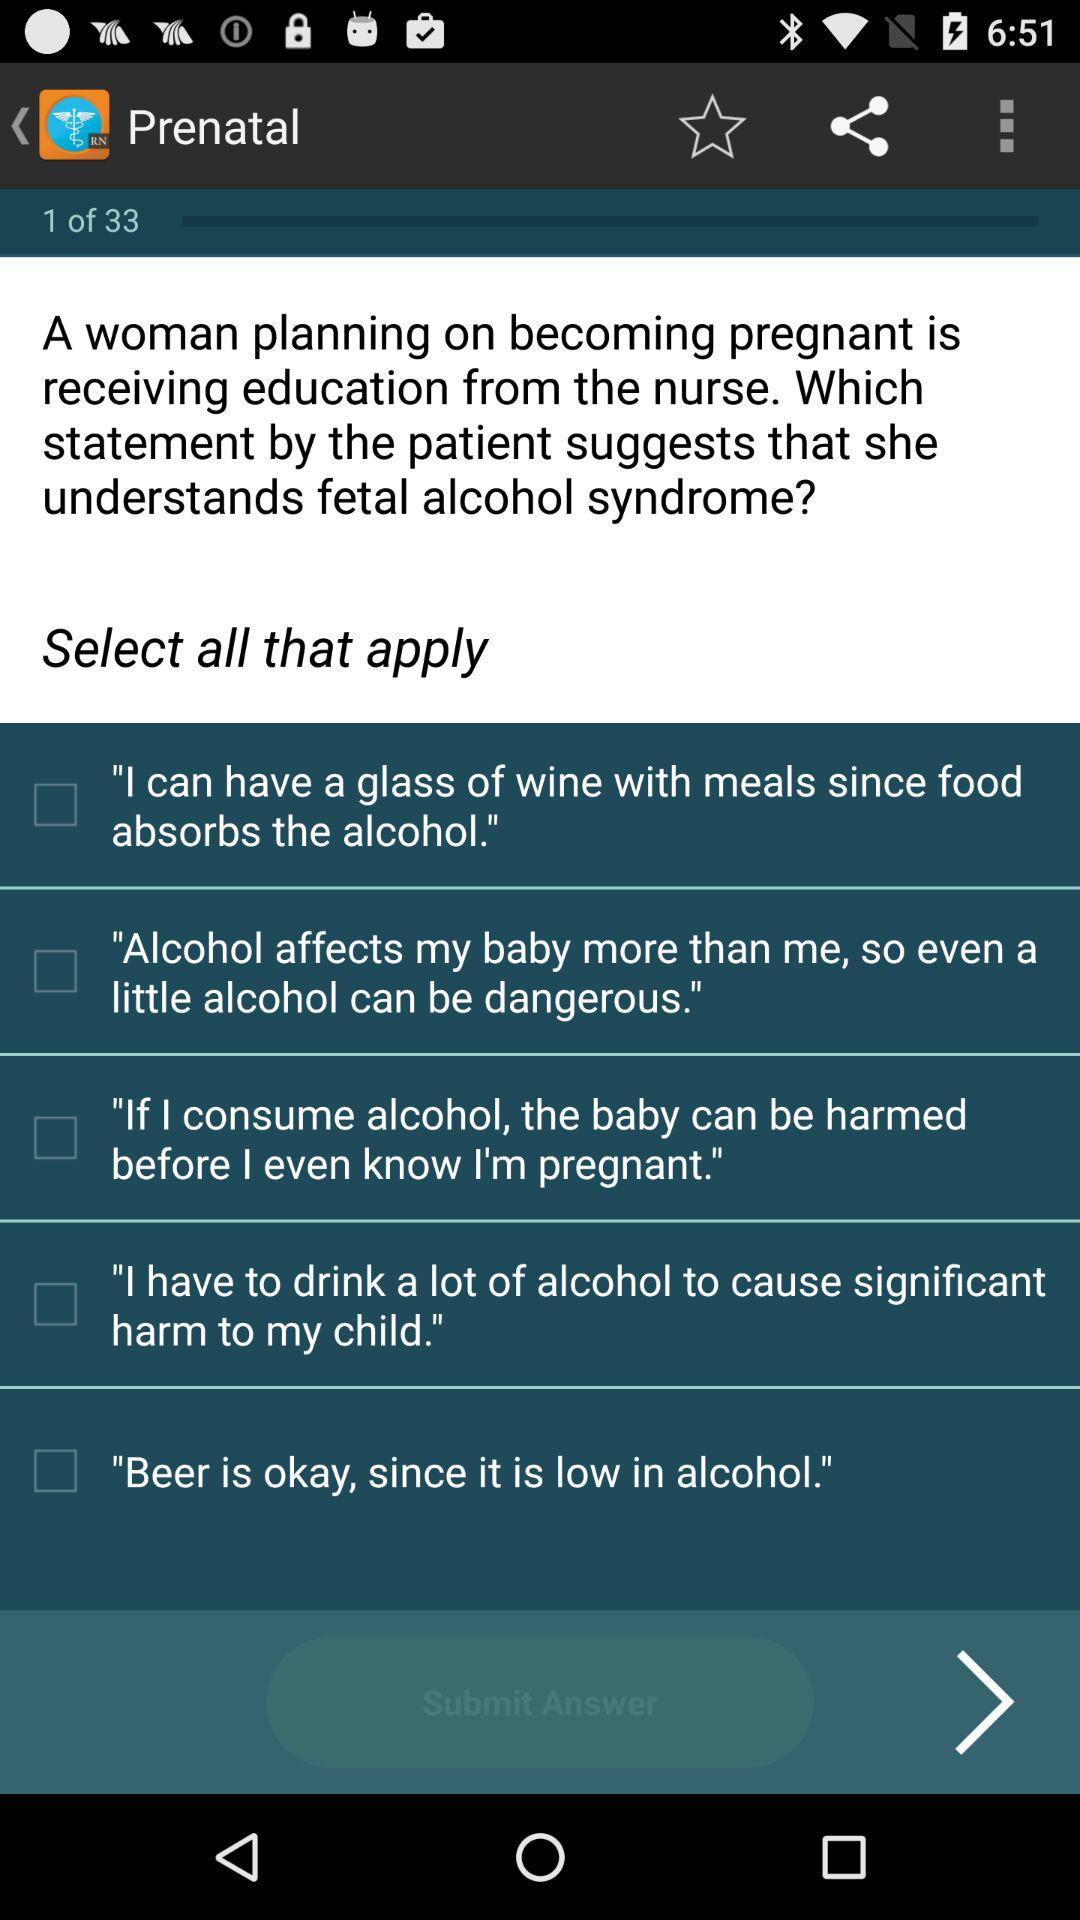What is the total number of questions? The total number of questions is 33. 